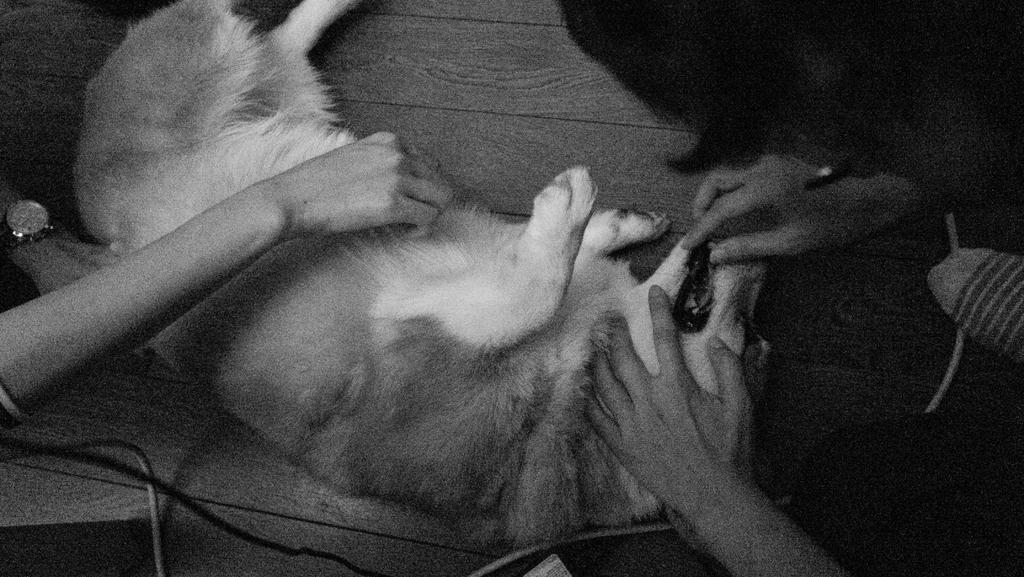What animal is present in the image? There is a dog in the image. Where is the dog located in the image? The dog is on the floor. Who else is present in the image? There is a person in the image. Where is the person located in the image? The person is on the right side of the image. What is the person doing to the dog in the image? The person is placing their hands on the dog's mouth. How is the person interacting with the dog in the image? The person's hand is on the dog in the image. Is there a stream of water flowing near the dog in the image? No, there is no stream of water present in the image. What type of bun is the person holding in the image? There is no bun present in the image; the person is placing their hands on the dog's mouth. 